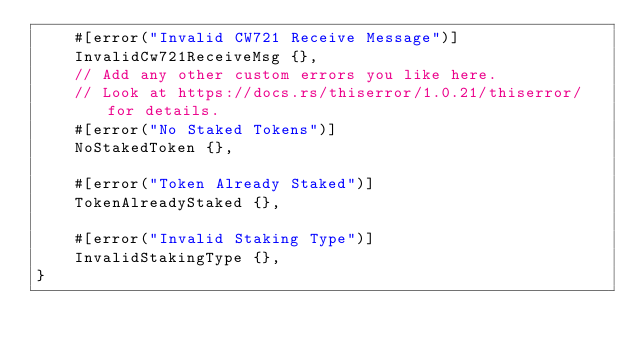Convert code to text. <code><loc_0><loc_0><loc_500><loc_500><_Rust_>    #[error("Invalid CW721 Receive Message")]
    InvalidCw721ReceiveMsg {},
    // Add any other custom errors you like here.
    // Look at https://docs.rs/thiserror/1.0.21/thiserror/ for details.
    #[error("No Staked Tokens")]
    NoStakedToken {},

    #[error("Token Already Staked")]
    TokenAlreadyStaked {},

    #[error("Invalid Staking Type")]
    InvalidStakingType {},
}
</code> 